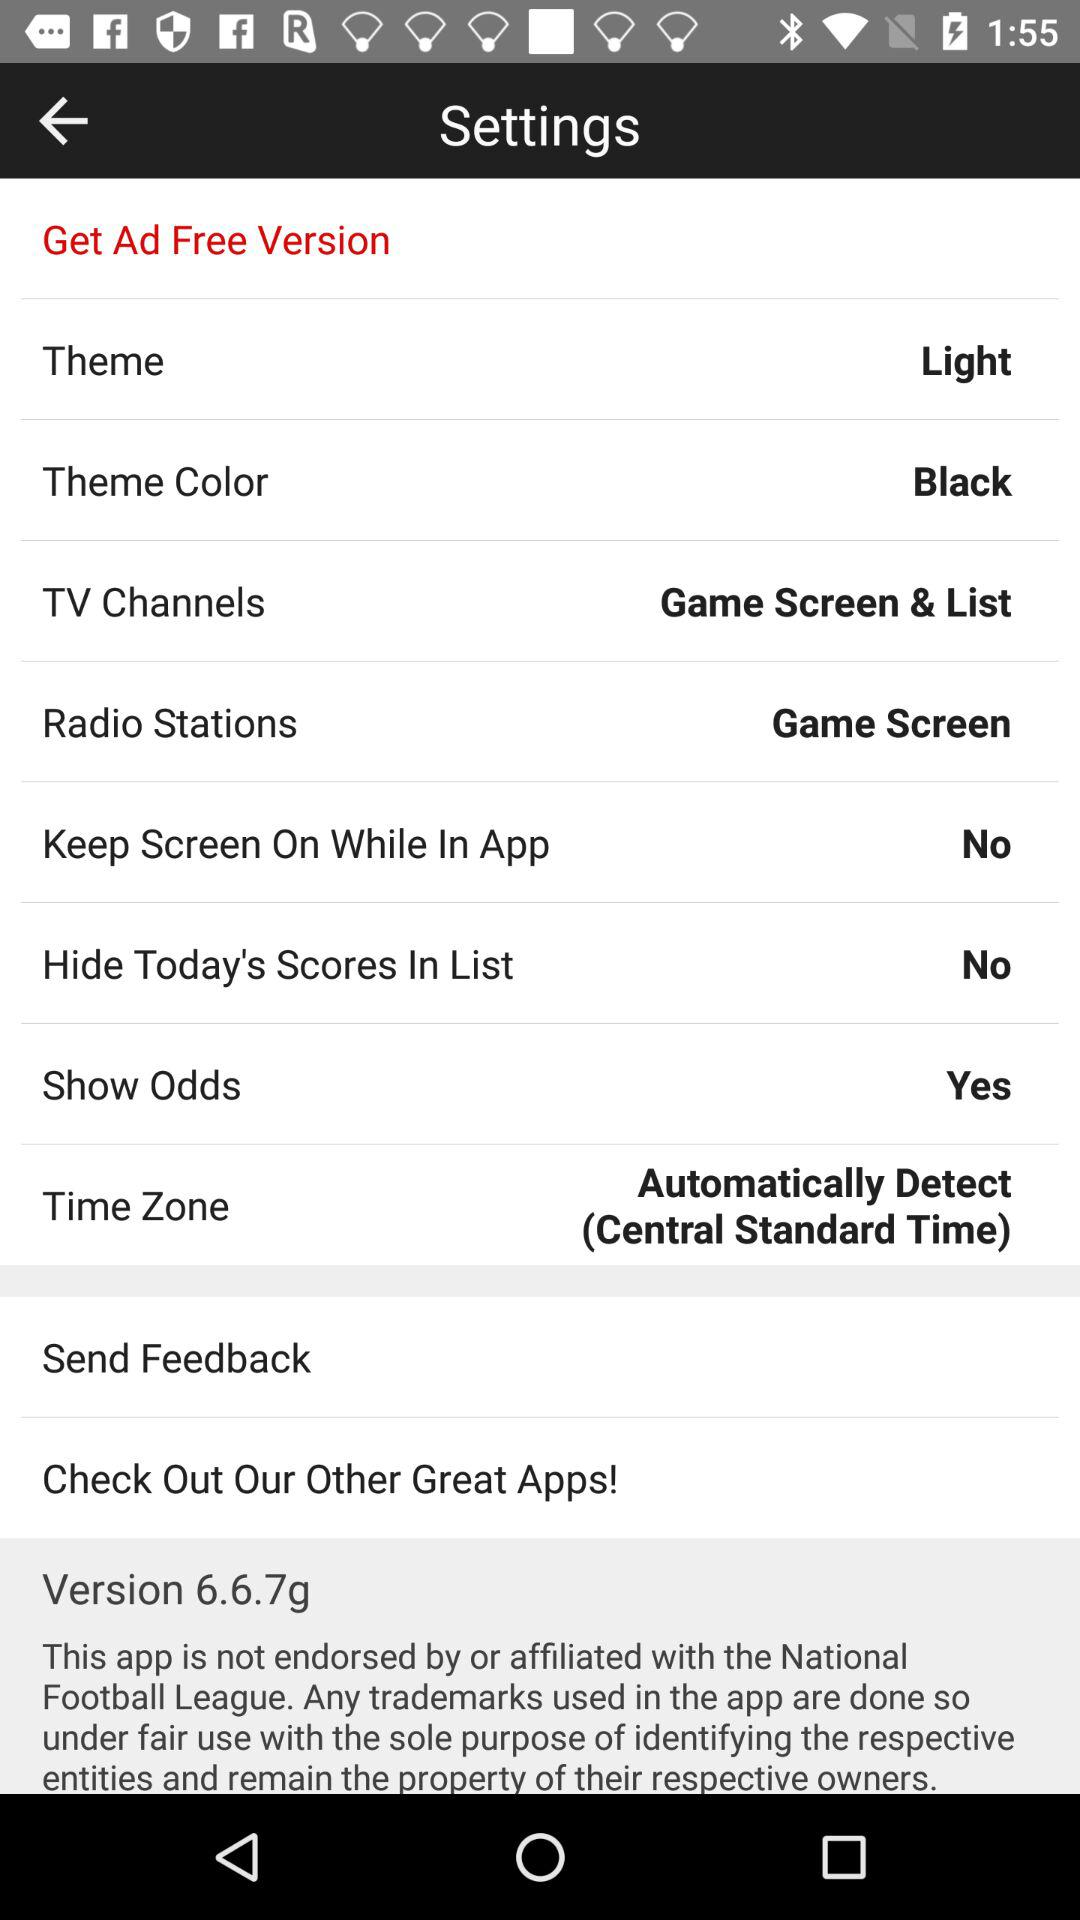What is the time zone? The time zone is "Automatically Detect (Central Standard Time)". 